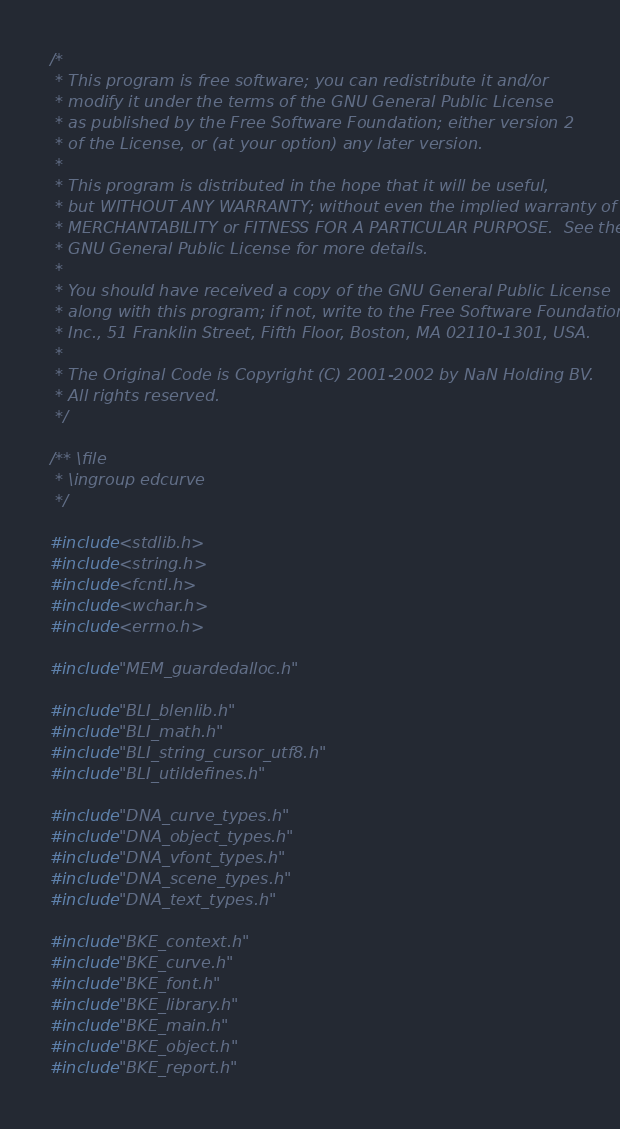Convert code to text. <code><loc_0><loc_0><loc_500><loc_500><_C_>/*
 * This program is free software; you can redistribute it and/or
 * modify it under the terms of the GNU General Public License
 * as published by the Free Software Foundation; either version 2
 * of the License, or (at your option) any later version.
 *
 * This program is distributed in the hope that it will be useful,
 * but WITHOUT ANY WARRANTY; without even the implied warranty of
 * MERCHANTABILITY or FITNESS FOR A PARTICULAR PURPOSE.  See the
 * GNU General Public License for more details.
 *
 * You should have received a copy of the GNU General Public License
 * along with this program; if not, write to the Free Software Foundation,
 * Inc., 51 Franklin Street, Fifth Floor, Boston, MA 02110-1301, USA.
 *
 * The Original Code is Copyright (C) 2001-2002 by NaN Holding BV.
 * All rights reserved.
 */

/** \file
 * \ingroup edcurve
 */

#include <stdlib.h>
#include <string.h>
#include <fcntl.h>
#include <wchar.h>
#include <errno.h>

#include "MEM_guardedalloc.h"

#include "BLI_blenlib.h"
#include "BLI_math.h"
#include "BLI_string_cursor_utf8.h"
#include "BLI_utildefines.h"

#include "DNA_curve_types.h"
#include "DNA_object_types.h"
#include "DNA_vfont_types.h"
#include "DNA_scene_types.h"
#include "DNA_text_types.h"

#include "BKE_context.h"
#include "BKE_curve.h"
#include "BKE_font.h"
#include "BKE_library.h"
#include "BKE_main.h"
#include "BKE_object.h"
#include "BKE_report.h"
</code> 